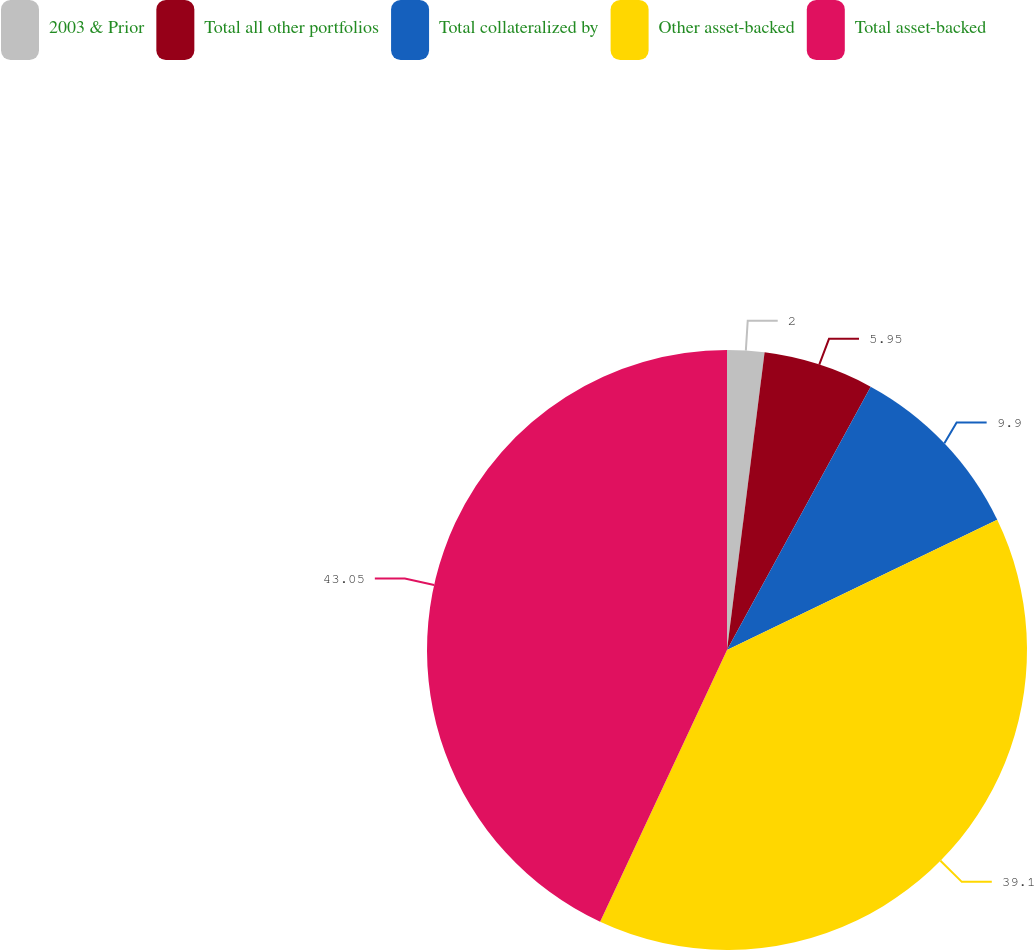Convert chart to OTSL. <chart><loc_0><loc_0><loc_500><loc_500><pie_chart><fcel>2003 & Prior<fcel>Total all other portfolios<fcel>Total collateralized by<fcel>Other asset-backed<fcel>Total asset-backed<nl><fcel>2.0%<fcel>5.95%<fcel>9.9%<fcel>39.1%<fcel>43.05%<nl></chart> 